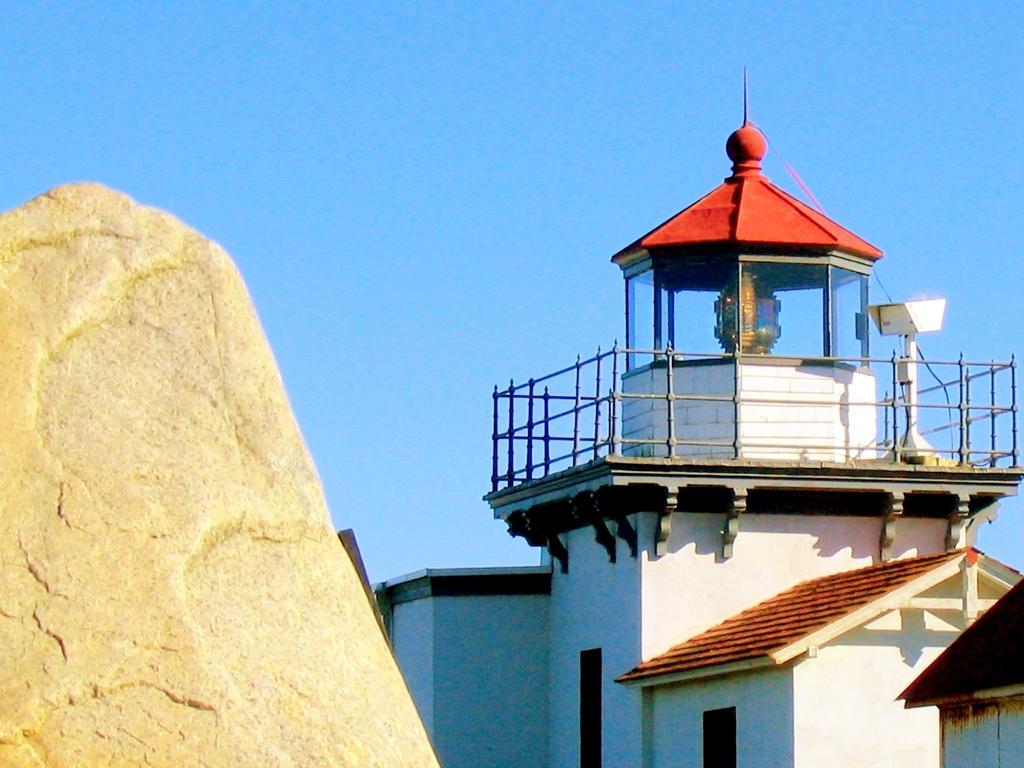How would you summarize this image in a sentence or two? In this image there is a house, on the left there is a stone, in the background there is a blue sky. 